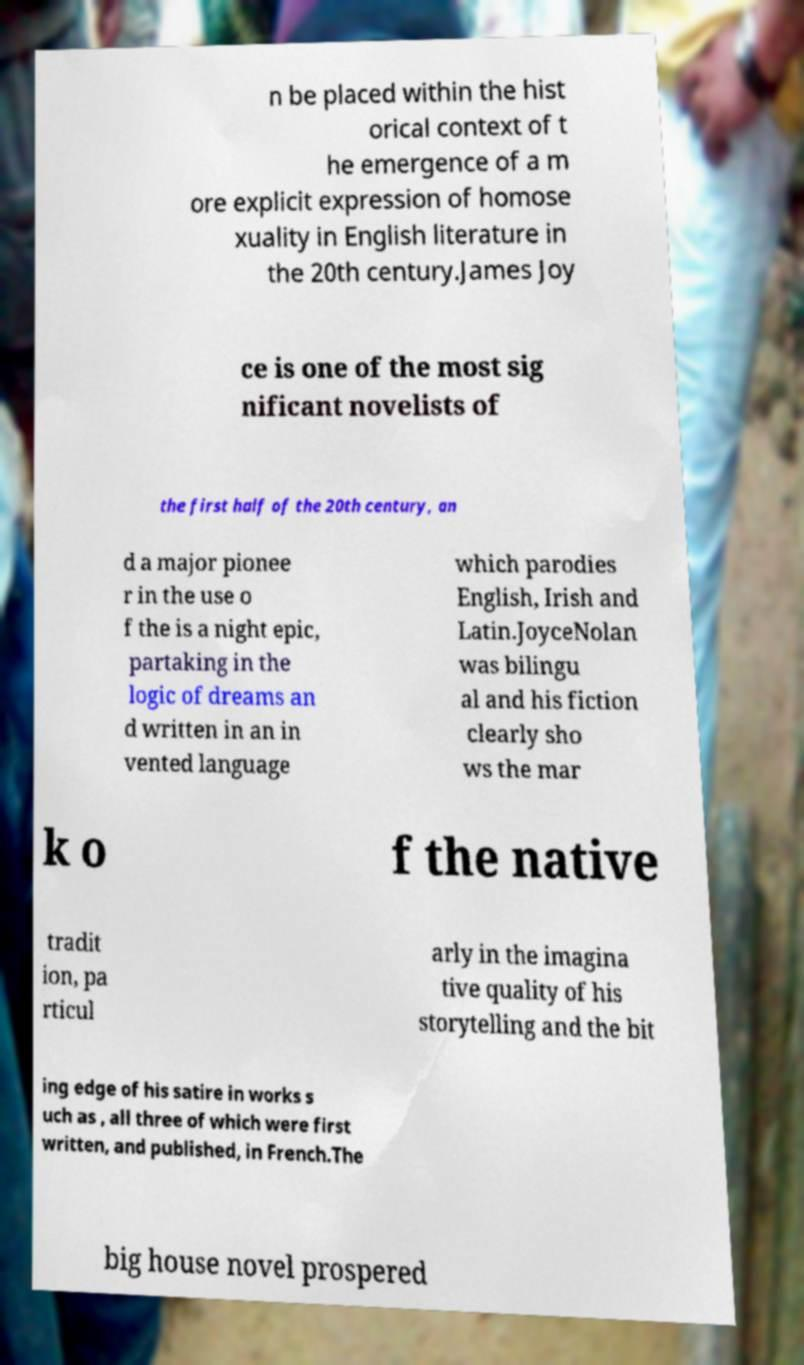There's text embedded in this image that I need extracted. Can you transcribe it verbatim? n be placed within the hist orical context of t he emergence of a m ore explicit expression of homose xuality in English literature in the 20th century.James Joy ce is one of the most sig nificant novelists of the first half of the 20th century, an d a major pionee r in the use o f the is a night epic, partaking in the logic of dreams an d written in an in vented language which parodies English, Irish and Latin.JoyceNolan was bilingu al and his fiction clearly sho ws the mar k o f the native tradit ion, pa rticul arly in the imagina tive quality of his storytelling and the bit ing edge of his satire in works s uch as , all three of which were first written, and published, in French.The big house novel prospered 